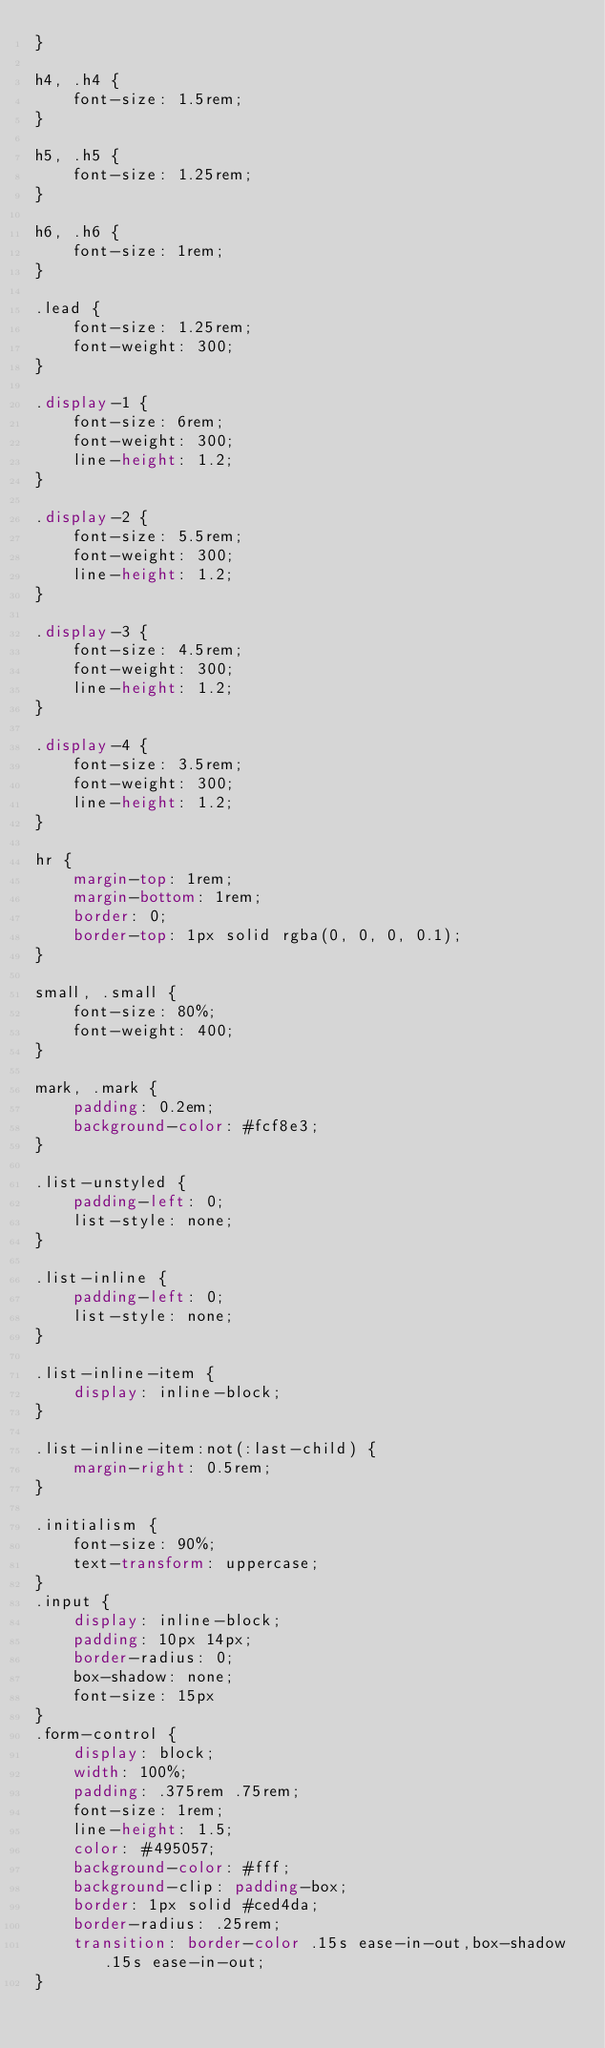Convert code to text. <code><loc_0><loc_0><loc_500><loc_500><_CSS_>}

h4, .h4 {
    font-size: 1.5rem;
}

h5, .h5 {
    font-size: 1.25rem;
}

h6, .h6 {
    font-size: 1rem;
}

.lead {
    font-size: 1.25rem;
    font-weight: 300;
}

.display-1 {
    font-size: 6rem;
    font-weight: 300;
    line-height: 1.2;
}

.display-2 {
    font-size: 5.5rem;
    font-weight: 300;
    line-height: 1.2;
}

.display-3 {
    font-size: 4.5rem;
    font-weight: 300;
    line-height: 1.2;
}

.display-4 {
    font-size: 3.5rem;
    font-weight: 300;
    line-height: 1.2;
}

hr {
    margin-top: 1rem;
    margin-bottom: 1rem;
    border: 0;
    border-top: 1px solid rgba(0, 0, 0, 0.1);
}

small, .small {
    font-size: 80%;
    font-weight: 400;
}

mark, .mark {
    padding: 0.2em;
    background-color: #fcf8e3;
}

.list-unstyled {
    padding-left: 0;
    list-style: none;
}

.list-inline {
    padding-left: 0;
    list-style: none;
}

.list-inline-item {
    display: inline-block;
}

.list-inline-item:not(:last-child) {
    margin-right: 0.5rem;
}

.initialism {
    font-size: 90%;
    text-transform: uppercase;
}
.input {
    display: inline-block;
    padding: 10px 14px;
    border-radius: 0;
    box-shadow: none;
    font-size: 15px
}
.form-control {
    display: block;
    width: 100%;
    padding: .375rem .75rem;
    font-size: 1rem;
    line-height: 1.5;
    color: #495057;
    background-color: #fff;
    background-clip: padding-box;
    border: 1px solid #ced4da;
    border-radius: .25rem;
    transition: border-color .15s ease-in-out,box-shadow .15s ease-in-out;
}</code> 